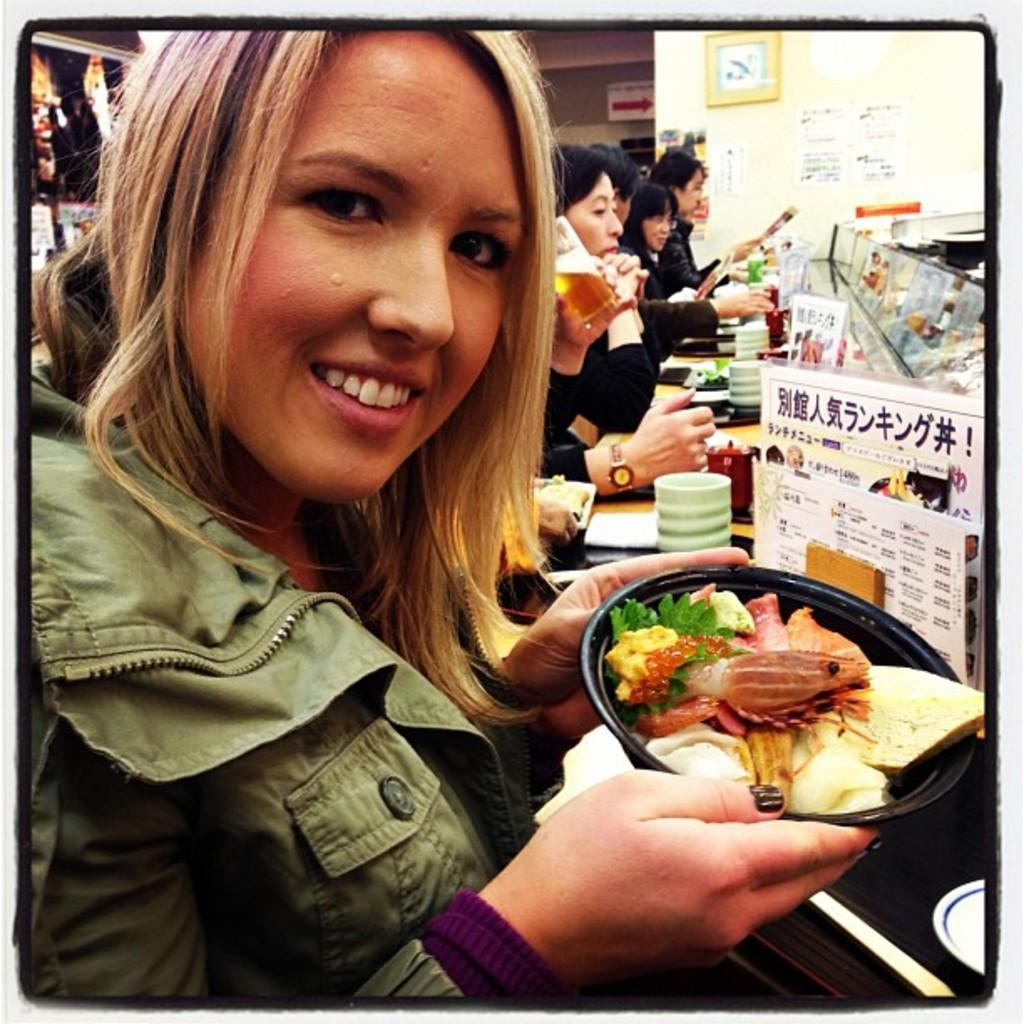Who is the main subject in the image? There is a woman in the image. What is the woman holding in her hand? The woman is holding a food item in her hand. What can be seen in the background of the image? There are people, a wall, a clock, a sign board, cups, and a poster in the background of the image. What song is the woman singing in the image? There is no indication in the image that the woman is singing a song, so it cannot be determined from the picture. 